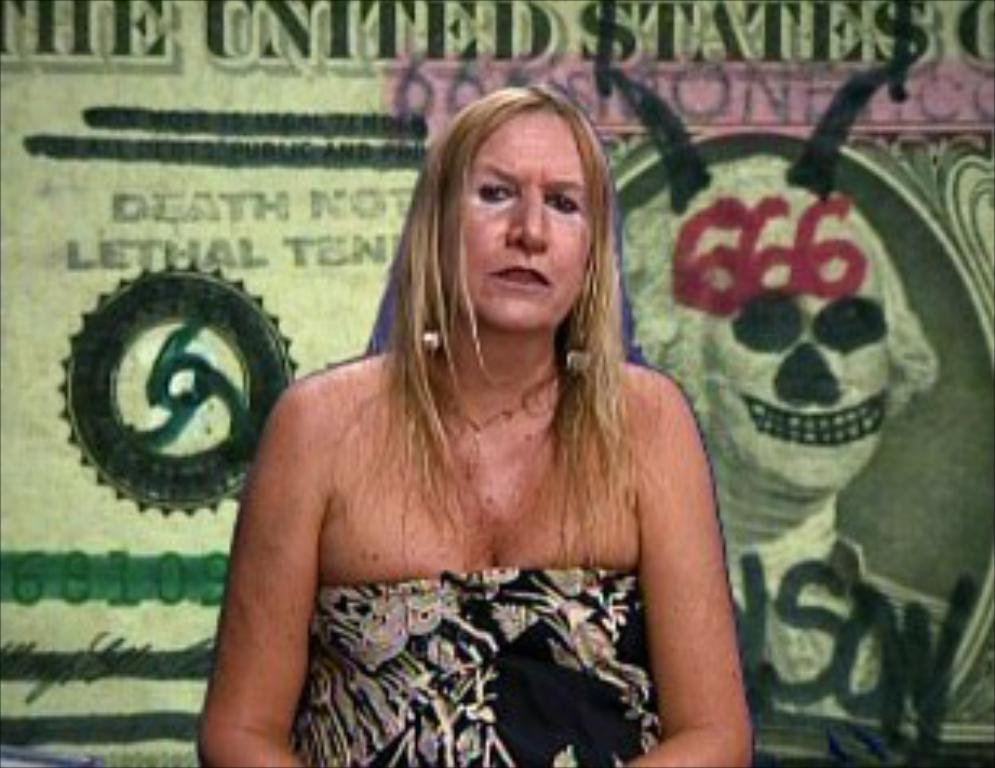What is the lady doing in the image? The lady is sitting in the image. What can be seen on the wall or background in the image? There is a poster with images in the image. What is written or depicted on the poster? There is something written on the poster. What type of nut is the lady holding in the image? There is no nut present in the image. What does the lady's mom say about the poster in the image? The lady's mom is not present in the image, so it's not possible to determine what she might say about the poster. 